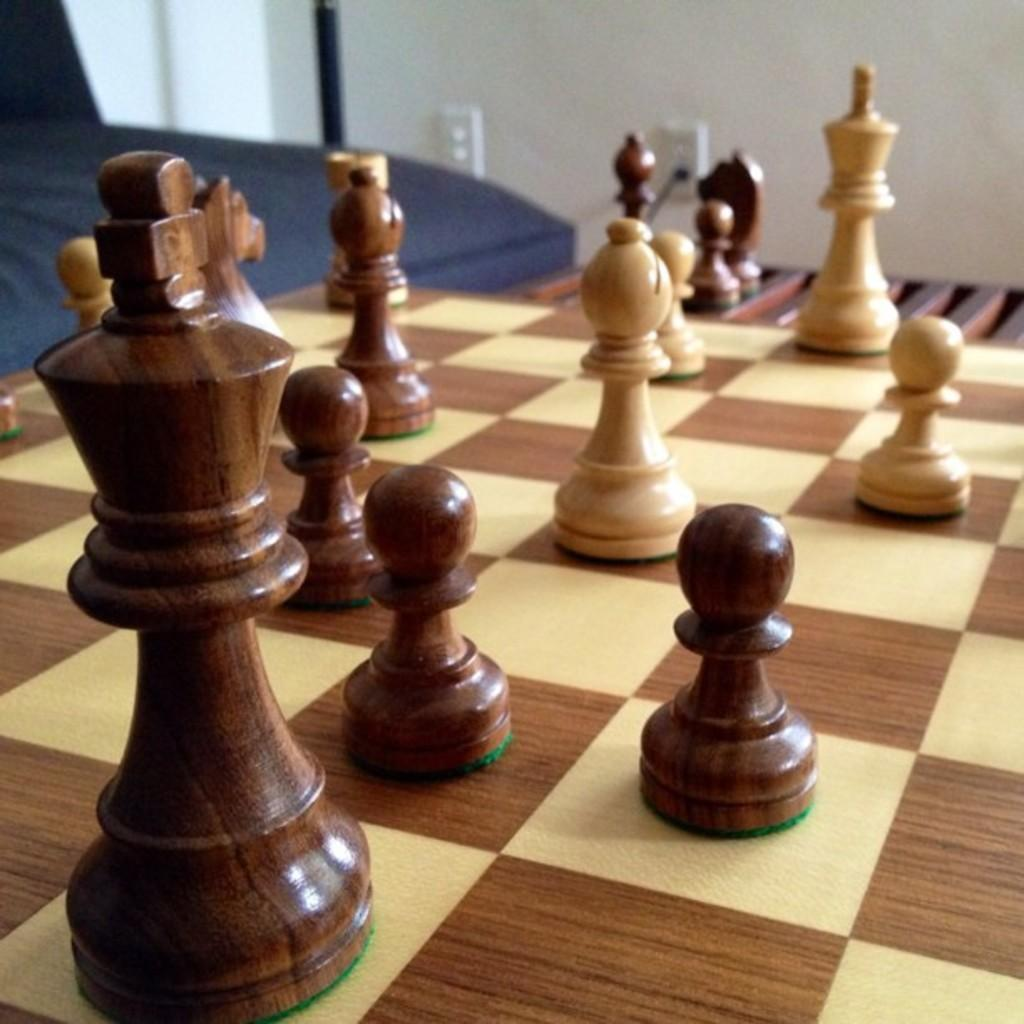What game is being played in the image? The game being played in the image is chess, as evidenced by the presence of a chess board and chess coins. What colors are used for the chess board? The chess board has a cream and brown color. Can you describe the pieces on the chess board? The chess coins are present on the board, indicating that the game is in progress. What type of book is being used as a sack in the image? There is no book or sack present in the image; it features a chess board and chess coins. 